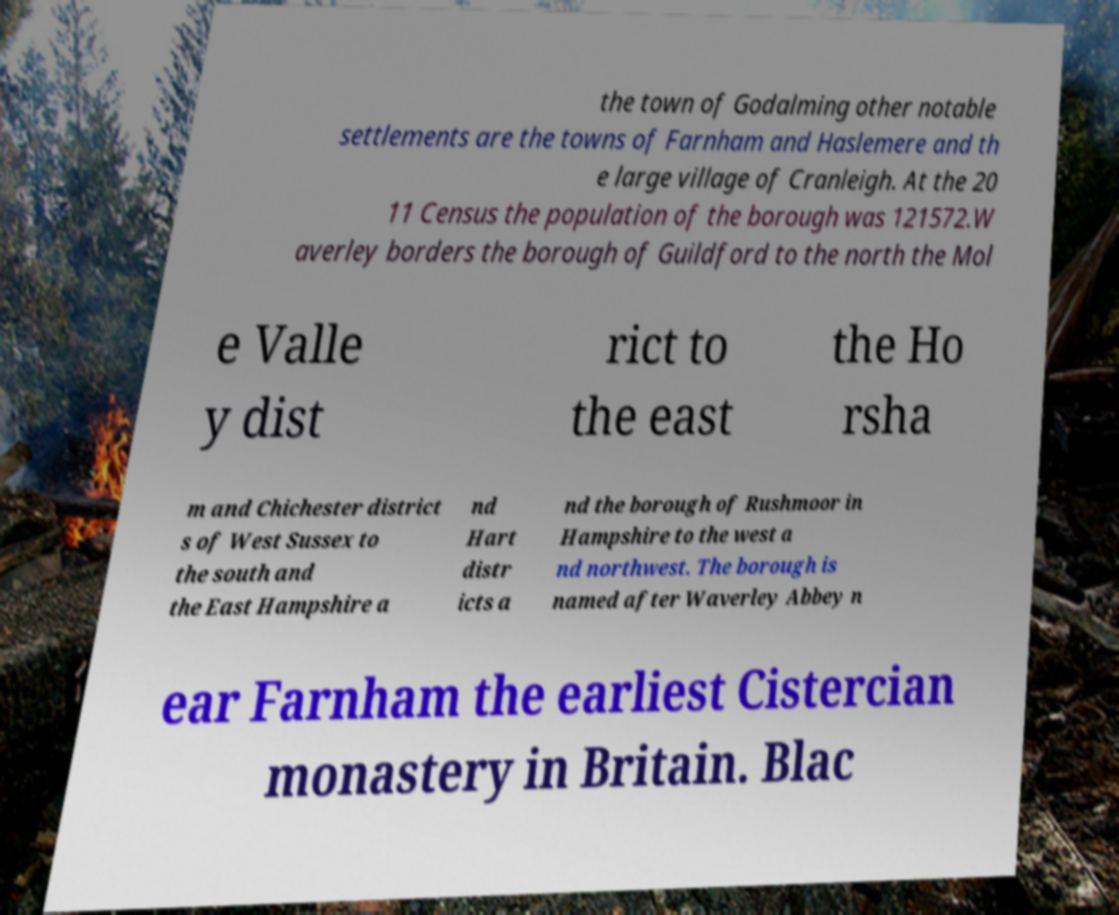For documentation purposes, I need the text within this image transcribed. Could you provide that? the town of Godalming other notable settlements are the towns of Farnham and Haslemere and th e large village of Cranleigh. At the 20 11 Census the population of the borough was 121572.W averley borders the borough of Guildford to the north the Mol e Valle y dist rict to the east the Ho rsha m and Chichester district s of West Sussex to the south and the East Hampshire a nd Hart distr icts a nd the borough of Rushmoor in Hampshire to the west a nd northwest. The borough is named after Waverley Abbey n ear Farnham the earliest Cistercian monastery in Britain. Blac 